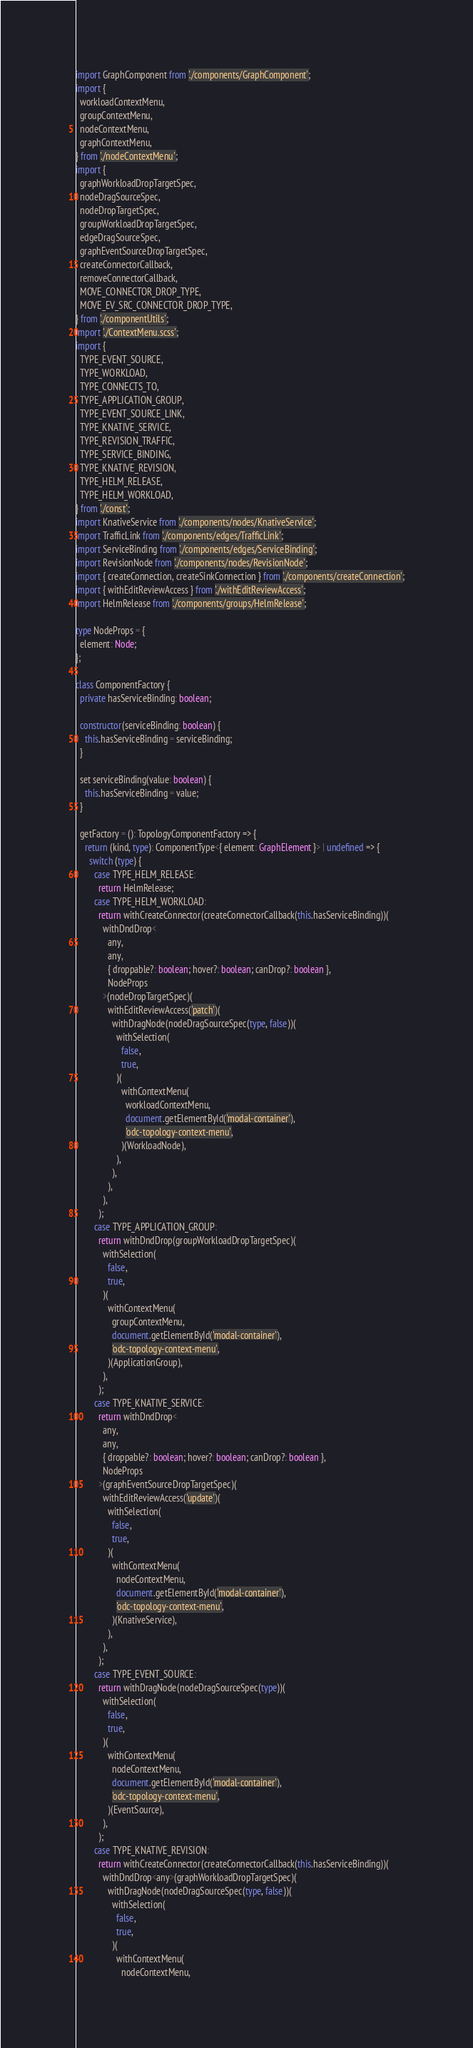<code> <loc_0><loc_0><loc_500><loc_500><_TypeScript_>import GraphComponent from './components/GraphComponent';
import {
  workloadContextMenu,
  groupContextMenu,
  nodeContextMenu,
  graphContextMenu,
} from './nodeContextMenu';
import {
  graphWorkloadDropTargetSpec,
  nodeDragSourceSpec,
  nodeDropTargetSpec,
  groupWorkloadDropTargetSpec,
  edgeDragSourceSpec,
  graphEventSourceDropTargetSpec,
  createConnectorCallback,
  removeConnectorCallback,
  MOVE_CONNECTOR_DROP_TYPE,
  MOVE_EV_SRC_CONNECTOR_DROP_TYPE,
} from './componentUtils';
import './ContextMenu.scss';
import {
  TYPE_EVENT_SOURCE,
  TYPE_WORKLOAD,
  TYPE_CONNECTS_TO,
  TYPE_APPLICATION_GROUP,
  TYPE_EVENT_SOURCE_LINK,
  TYPE_KNATIVE_SERVICE,
  TYPE_REVISION_TRAFFIC,
  TYPE_SERVICE_BINDING,
  TYPE_KNATIVE_REVISION,
  TYPE_HELM_RELEASE,
  TYPE_HELM_WORKLOAD,
} from './const';
import KnativeService from './components/nodes/KnativeService';
import TrafficLink from './components/edges/TrafficLink';
import ServiceBinding from './components/edges/ServiceBinding';
import RevisionNode from './components/nodes/RevisionNode';
import { createConnection, createSinkConnection } from './components/createConnection';
import { withEditReviewAccess } from './withEditReviewAccess';
import HelmRelease from './components/groups/HelmRelease';

type NodeProps = {
  element: Node;
};

class ComponentFactory {
  private hasServiceBinding: boolean;

  constructor(serviceBinding: boolean) {
    this.hasServiceBinding = serviceBinding;
  }

  set serviceBinding(value: boolean) {
    this.hasServiceBinding = value;
  }

  getFactory = (): TopologyComponentFactory => {
    return (kind, type): ComponentType<{ element: GraphElement }> | undefined => {
      switch (type) {
        case TYPE_HELM_RELEASE:
          return HelmRelease;
        case TYPE_HELM_WORKLOAD:
          return withCreateConnector(createConnectorCallback(this.hasServiceBinding))(
            withDndDrop<
              any,
              any,
              { droppable?: boolean; hover?: boolean; canDrop?: boolean },
              NodeProps
            >(nodeDropTargetSpec)(
              withEditReviewAccess('patch')(
                withDragNode(nodeDragSourceSpec(type, false))(
                  withSelection(
                    false,
                    true,
                  )(
                    withContextMenu(
                      workloadContextMenu,
                      document.getElementById('modal-container'),
                      'odc-topology-context-menu',
                    )(WorkloadNode),
                  ),
                ),
              ),
            ),
          );
        case TYPE_APPLICATION_GROUP:
          return withDndDrop(groupWorkloadDropTargetSpec)(
            withSelection(
              false,
              true,
            )(
              withContextMenu(
                groupContextMenu,
                document.getElementById('modal-container'),
                'odc-topology-context-menu',
              )(ApplicationGroup),
            ),
          );
        case TYPE_KNATIVE_SERVICE:
          return withDndDrop<
            any,
            any,
            { droppable?: boolean; hover?: boolean; canDrop?: boolean },
            NodeProps
          >(graphEventSourceDropTargetSpec)(
            withEditReviewAccess('update')(
              withSelection(
                false,
                true,
              )(
                withContextMenu(
                  nodeContextMenu,
                  document.getElementById('modal-container'),
                  'odc-topology-context-menu',
                )(KnativeService),
              ),
            ),
          );
        case TYPE_EVENT_SOURCE:
          return withDragNode(nodeDragSourceSpec(type))(
            withSelection(
              false,
              true,
            )(
              withContextMenu(
                nodeContextMenu,
                document.getElementById('modal-container'),
                'odc-topology-context-menu',
              )(EventSource),
            ),
          );
        case TYPE_KNATIVE_REVISION:
          return withCreateConnector(createConnectorCallback(this.hasServiceBinding))(
            withDndDrop<any>(graphWorkloadDropTargetSpec)(
              withDragNode(nodeDragSourceSpec(type, false))(
                withSelection(
                  false,
                  true,
                )(
                  withContextMenu(
                    nodeContextMenu,</code> 